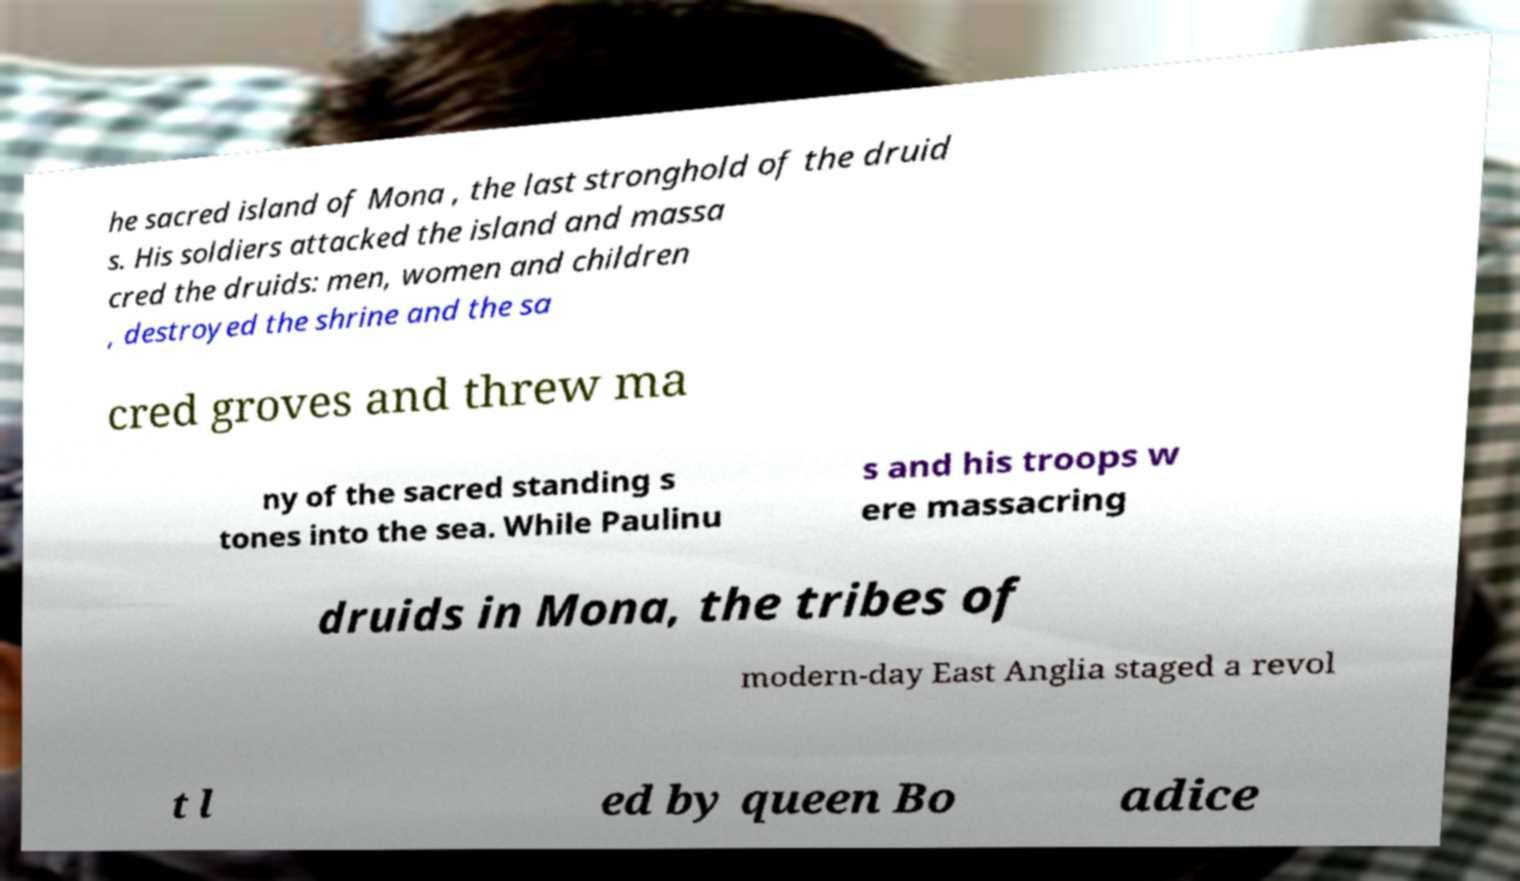For documentation purposes, I need the text within this image transcribed. Could you provide that? he sacred island of Mona , the last stronghold of the druid s. His soldiers attacked the island and massa cred the druids: men, women and children , destroyed the shrine and the sa cred groves and threw ma ny of the sacred standing s tones into the sea. While Paulinu s and his troops w ere massacring druids in Mona, the tribes of modern-day East Anglia staged a revol t l ed by queen Bo adice 